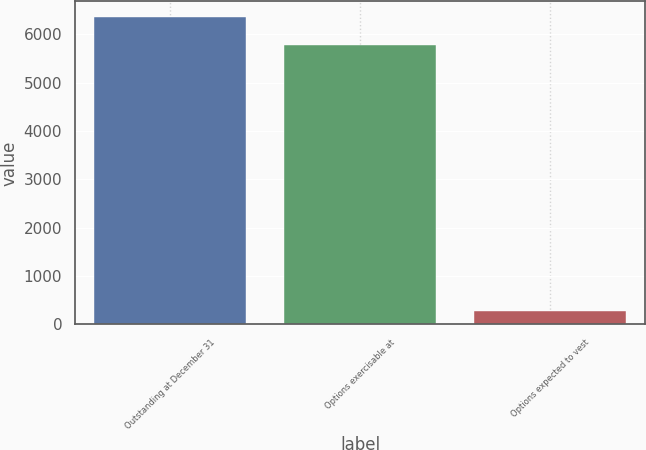Convert chart to OTSL. <chart><loc_0><loc_0><loc_500><loc_500><bar_chart><fcel>Outstanding at December 31<fcel>Options exercisable at<fcel>Options expected to vest<nl><fcel>6363.7<fcel>5785<fcel>279<nl></chart> 